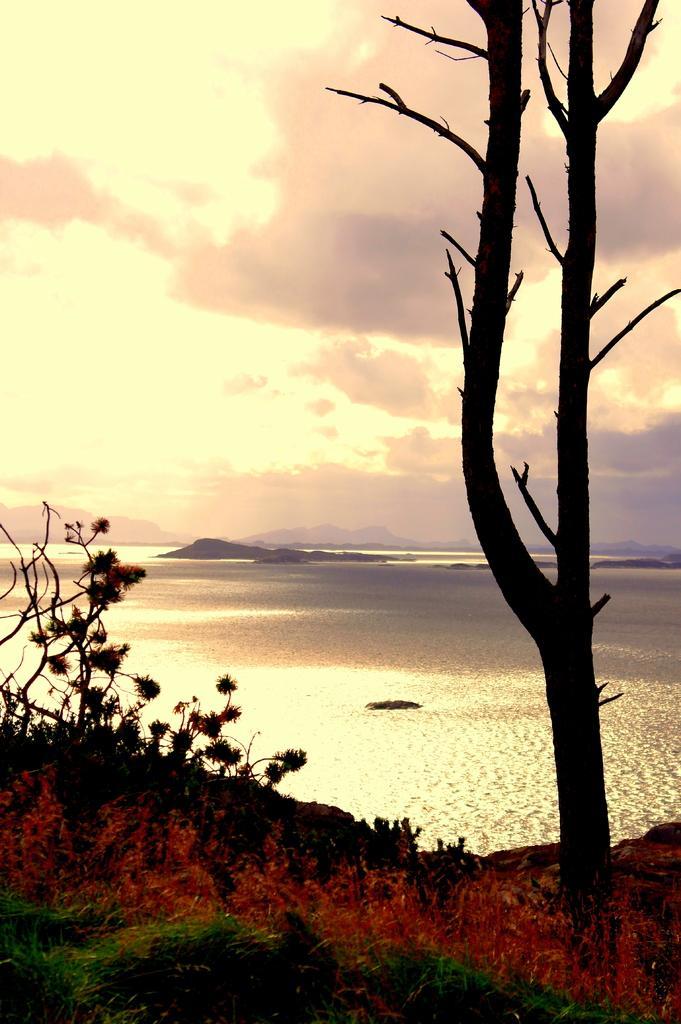How would you summarize this image in a sentence or two? In this image, at the bottom it seems like fire and there are plants. On the right there is a tree. In the background there are hills, water, sky and clouds. 